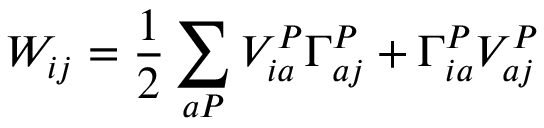Convert formula to latex. <formula><loc_0><loc_0><loc_500><loc_500>W _ { i j } = \frac { 1 } { 2 } \sum _ { a P } V _ { i a } ^ { P } \Gamma _ { a j } ^ { P } + \Gamma _ { i a } ^ { P } V _ { a j } ^ { P }</formula> 